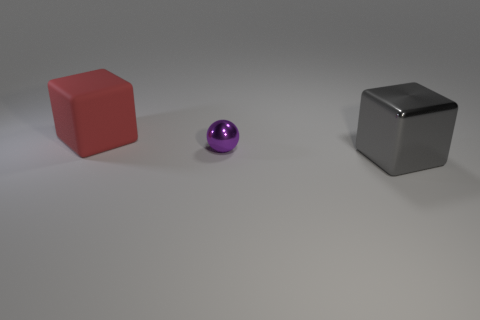Do the large object that is on the right side of the red matte cube and the big red object have the same shape?
Offer a very short reply. Yes. The shiny thing behind the big gray metallic thing has what shape?
Your answer should be very brief. Sphere. How many shiny objects are the same size as the red cube?
Your answer should be very brief. 1. The metal ball has what color?
Keep it short and to the point. Purple. What size is the cube that is the same material as the sphere?
Keep it short and to the point. Large. How many things are cubes to the left of the large gray thing or big shiny balls?
Your response must be concise. 1. Does the tiny purple sphere have the same material as the cube right of the red object?
Provide a succinct answer. Yes. Is there a big gray thing that has the same material as the ball?
Give a very brief answer. Yes. What number of objects are either cubes on the left side of the shiny ball or objects that are on the left side of the large gray block?
Ensure brevity in your answer.  2. There is a large red matte thing; is it the same shape as the big object that is on the right side of the big red rubber thing?
Give a very brief answer. Yes. 